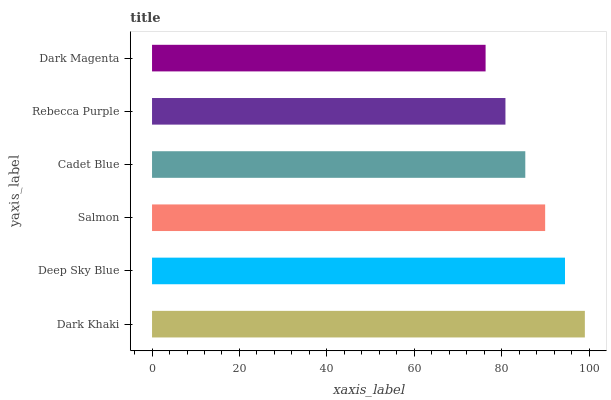Is Dark Magenta the minimum?
Answer yes or no. Yes. Is Dark Khaki the maximum?
Answer yes or no. Yes. Is Deep Sky Blue the minimum?
Answer yes or no. No. Is Deep Sky Blue the maximum?
Answer yes or no. No. Is Dark Khaki greater than Deep Sky Blue?
Answer yes or no. Yes. Is Deep Sky Blue less than Dark Khaki?
Answer yes or no. Yes. Is Deep Sky Blue greater than Dark Khaki?
Answer yes or no. No. Is Dark Khaki less than Deep Sky Blue?
Answer yes or no. No. Is Salmon the high median?
Answer yes or no. Yes. Is Cadet Blue the low median?
Answer yes or no. Yes. Is Dark Khaki the high median?
Answer yes or no. No. Is Deep Sky Blue the low median?
Answer yes or no. No. 